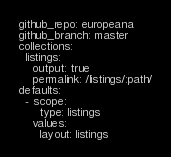Convert code to text. <code><loc_0><loc_0><loc_500><loc_500><_YAML_>github_repo: europeana
github_branch: master
collections:
  listings:
    output: true
    permalink: /listings/:path/
defaults:
  - scope:
      type: listings
    values:
      layout: listings
</code> 